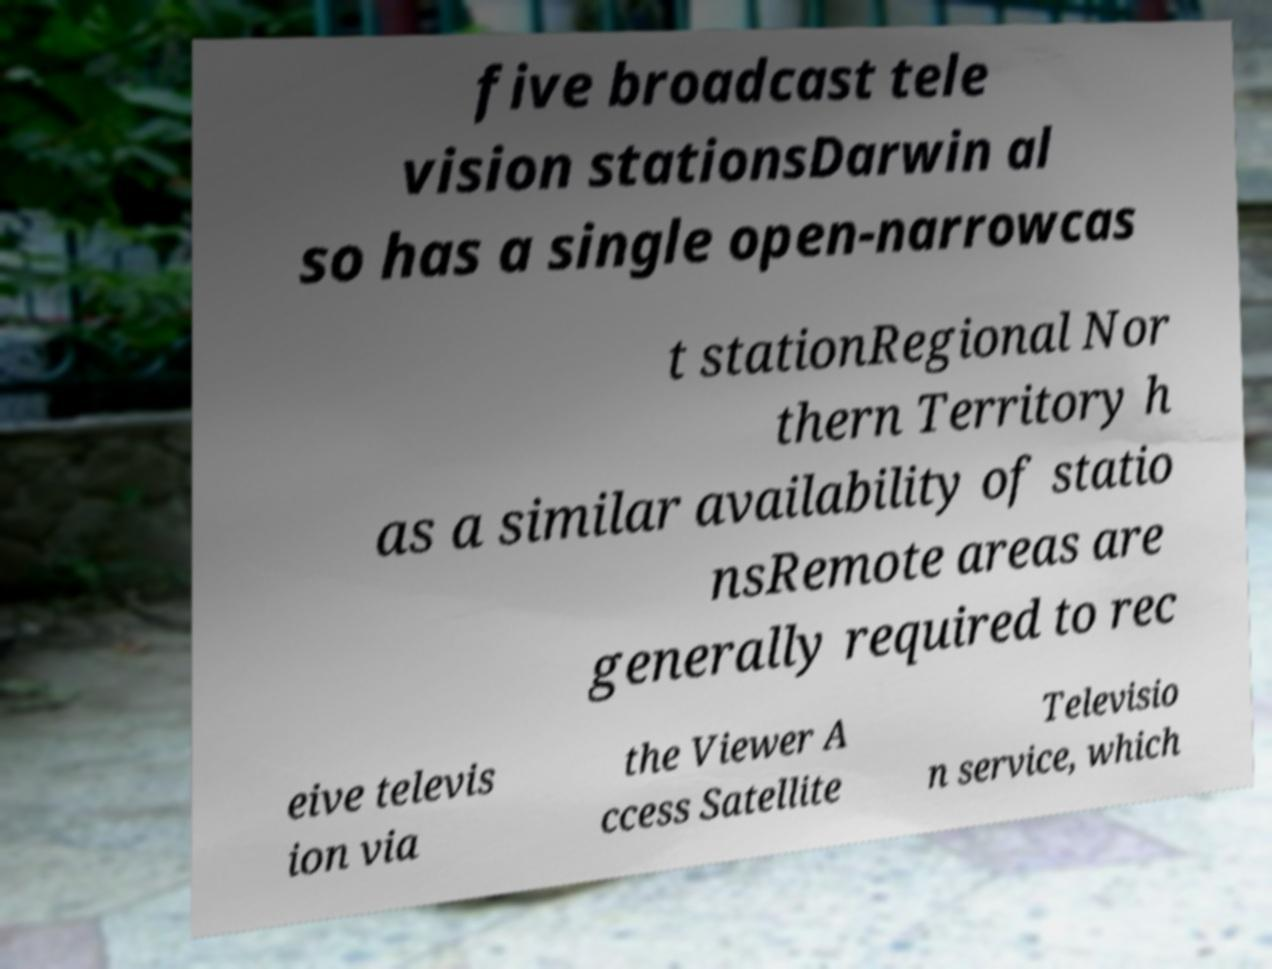For documentation purposes, I need the text within this image transcribed. Could you provide that? five broadcast tele vision stationsDarwin al so has a single open-narrowcas t stationRegional Nor thern Territory h as a similar availability of statio nsRemote areas are generally required to rec eive televis ion via the Viewer A ccess Satellite Televisio n service, which 